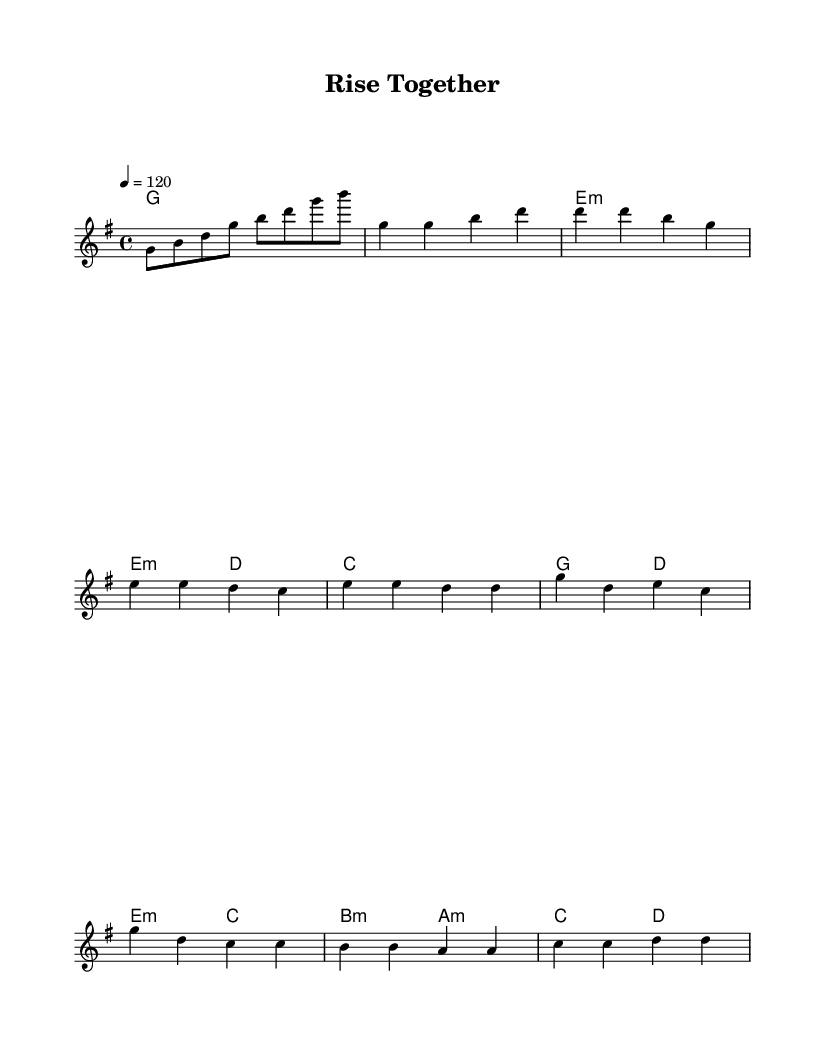What is the key signature of this music? The key signature is G major, which has one sharp (F#) in its scale.
Answer: G major What is the time signature of this music? The time signature is 4/4, indicating that there are four beats per measure.
Answer: 4/4 What is the tempo marking of this piece? The tempo marking is 120 beats per minute, signified by the notation "4 = 120".
Answer: 120 How many measures are in the chorus section? The chorus section consists of two measures, as indicated by the corresponding notes in the sheet music.
Answer: 2 What type of chords are used in the pre-chorus section? The pre-chorus section includes minor chords, specifically E minor and D major chords.
Answer: Minor chords Which note is the last note in the melody? The last note in the melody is D, as observed in the final measure.
Answer: D What is the relationship of the chorus to the verse in this piece? The chorus section repeats a melodic phrase related to the verse, emphasizing the thematic connection between them, typical in pop music structure.
Answer: Repetitive 